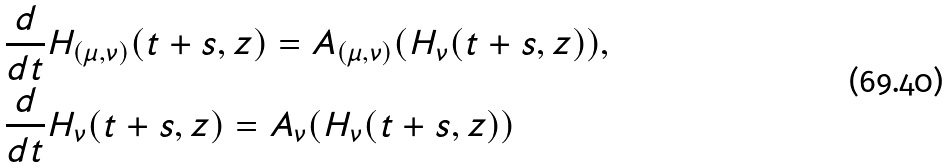<formula> <loc_0><loc_0><loc_500><loc_500>& \frac { d } { d t } H _ { ( \mu , \nu ) } ( t + s , z ) = A _ { ( \mu , \nu ) } ( H _ { \nu } ( t + s , z ) ) , \\ & \frac { d } { d t } H _ { \nu } ( t + s , z ) = A _ { \nu } ( H _ { \nu } ( t + s , z ) )</formula> 